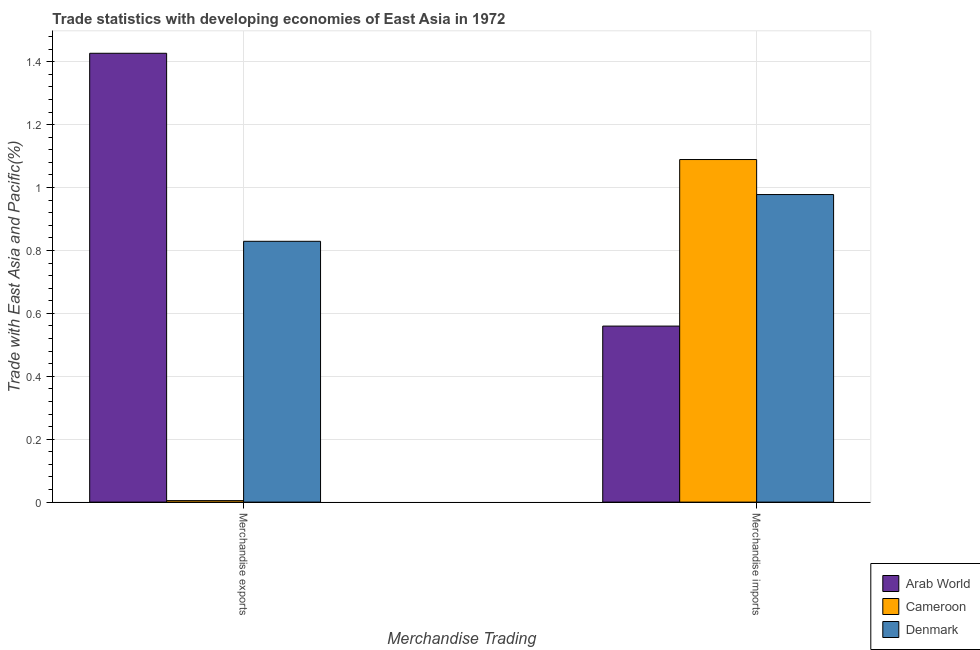How many different coloured bars are there?
Provide a succinct answer. 3. How many groups of bars are there?
Offer a very short reply. 2. Are the number of bars per tick equal to the number of legend labels?
Ensure brevity in your answer.  Yes. Are the number of bars on each tick of the X-axis equal?
Give a very brief answer. Yes. How many bars are there on the 1st tick from the left?
Ensure brevity in your answer.  3. How many bars are there on the 1st tick from the right?
Offer a very short reply. 3. What is the label of the 1st group of bars from the left?
Offer a terse response. Merchandise exports. What is the merchandise exports in Denmark?
Your answer should be compact. 0.83. Across all countries, what is the maximum merchandise exports?
Give a very brief answer. 1.43. Across all countries, what is the minimum merchandise imports?
Make the answer very short. 0.56. In which country was the merchandise exports maximum?
Ensure brevity in your answer.  Arab World. In which country was the merchandise imports minimum?
Make the answer very short. Arab World. What is the total merchandise imports in the graph?
Keep it short and to the point. 2.63. What is the difference between the merchandise imports in Cameroon and that in Denmark?
Offer a terse response. 0.11. What is the difference between the merchandise exports in Denmark and the merchandise imports in Arab World?
Give a very brief answer. 0.27. What is the average merchandise imports per country?
Offer a terse response. 0.88. What is the difference between the merchandise imports and merchandise exports in Denmark?
Keep it short and to the point. 0.15. In how many countries, is the merchandise imports greater than 0.24000000000000002 %?
Keep it short and to the point. 3. What is the ratio of the merchandise exports in Cameroon to that in Arab World?
Ensure brevity in your answer.  0. Is the merchandise imports in Arab World less than that in Denmark?
Make the answer very short. Yes. In how many countries, is the merchandise exports greater than the average merchandise exports taken over all countries?
Offer a terse response. 2. What does the 1st bar from the left in Merchandise imports represents?
Keep it short and to the point. Arab World. What does the 2nd bar from the right in Merchandise imports represents?
Offer a very short reply. Cameroon. Are all the bars in the graph horizontal?
Your answer should be very brief. No. Does the graph contain grids?
Give a very brief answer. Yes. Where does the legend appear in the graph?
Offer a terse response. Bottom right. How many legend labels are there?
Make the answer very short. 3. What is the title of the graph?
Your response must be concise. Trade statistics with developing economies of East Asia in 1972. What is the label or title of the X-axis?
Ensure brevity in your answer.  Merchandise Trading. What is the label or title of the Y-axis?
Make the answer very short. Trade with East Asia and Pacific(%). What is the Trade with East Asia and Pacific(%) of Arab World in Merchandise exports?
Provide a succinct answer. 1.43. What is the Trade with East Asia and Pacific(%) in Cameroon in Merchandise exports?
Make the answer very short. 0. What is the Trade with East Asia and Pacific(%) of Denmark in Merchandise exports?
Keep it short and to the point. 0.83. What is the Trade with East Asia and Pacific(%) of Arab World in Merchandise imports?
Offer a terse response. 0.56. What is the Trade with East Asia and Pacific(%) of Cameroon in Merchandise imports?
Make the answer very short. 1.09. What is the Trade with East Asia and Pacific(%) in Denmark in Merchandise imports?
Provide a short and direct response. 0.98. Across all Merchandise Trading, what is the maximum Trade with East Asia and Pacific(%) in Arab World?
Offer a very short reply. 1.43. Across all Merchandise Trading, what is the maximum Trade with East Asia and Pacific(%) of Cameroon?
Your answer should be very brief. 1.09. Across all Merchandise Trading, what is the maximum Trade with East Asia and Pacific(%) in Denmark?
Keep it short and to the point. 0.98. Across all Merchandise Trading, what is the minimum Trade with East Asia and Pacific(%) in Arab World?
Provide a short and direct response. 0.56. Across all Merchandise Trading, what is the minimum Trade with East Asia and Pacific(%) in Cameroon?
Make the answer very short. 0. Across all Merchandise Trading, what is the minimum Trade with East Asia and Pacific(%) of Denmark?
Keep it short and to the point. 0.83. What is the total Trade with East Asia and Pacific(%) of Arab World in the graph?
Your response must be concise. 1.99. What is the total Trade with East Asia and Pacific(%) of Cameroon in the graph?
Your answer should be compact. 1.09. What is the total Trade with East Asia and Pacific(%) of Denmark in the graph?
Give a very brief answer. 1.81. What is the difference between the Trade with East Asia and Pacific(%) of Arab World in Merchandise exports and that in Merchandise imports?
Provide a succinct answer. 0.87. What is the difference between the Trade with East Asia and Pacific(%) of Cameroon in Merchandise exports and that in Merchandise imports?
Give a very brief answer. -1.08. What is the difference between the Trade with East Asia and Pacific(%) of Denmark in Merchandise exports and that in Merchandise imports?
Offer a very short reply. -0.15. What is the difference between the Trade with East Asia and Pacific(%) in Arab World in Merchandise exports and the Trade with East Asia and Pacific(%) in Cameroon in Merchandise imports?
Provide a succinct answer. 0.34. What is the difference between the Trade with East Asia and Pacific(%) of Arab World in Merchandise exports and the Trade with East Asia and Pacific(%) of Denmark in Merchandise imports?
Provide a succinct answer. 0.45. What is the difference between the Trade with East Asia and Pacific(%) in Cameroon in Merchandise exports and the Trade with East Asia and Pacific(%) in Denmark in Merchandise imports?
Provide a succinct answer. -0.97. What is the average Trade with East Asia and Pacific(%) of Arab World per Merchandise Trading?
Make the answer very short. 0.99. What is the average Trade with East Asia and Pacific(%) of Cameroon per Merchandise Trading?
Provide a succinct answer. 0.55. What is the average Trade with East Asia and Pacific(%) in Denmark per Merchandise Trading?
Provide a short and direct response. 0.9. What is the difference between the Trade with East Asia and Pacific(%) in Arab World and Trade with East Asia and Pacific(%) in Cameroon in Merchandise exports?
Provide a short and direct response. 1.42. What is the difference between the Trade with East Asia and Pacific(%) in Arab World and Trade with East Asia and Pacific(%) in Denmark in Merchandise exports?
Provide a succinct answer. 0.6. What is the difference between the Trade with East Asia and Pacific(%) of Cameroon and Trade with East Asia and Pacific(%) of Denmark in Merchandise exports?
Provide a succinct answer. -0.82. What is the difference between the Trade with East Asia and Pacific(%) in Arab World and Trade with East Asia and Pacific(%) in Cameroon in Merchandise imports?
Your answer should be very brief. -0.53. What is the difference between the Trade with East Asia and Pacific(%) of Arab World and Trade with East Asia and Pacific(%) of Denmark in Merchandise imports?
Ensure brevity in your answer.  -0.42. What is the difference between the Trade with East Asia and Pacific(%) in Cameroon and Trade with East Asia and Pacific(%) in Denmark in Merchandise imports?
Offer a very short reply. 0.11. What is the ratio of the Trade with East Asia and Pacific(%) in Arab World in Merchandise exports to that in Merchandise imports?
Your response must be concise. 2.55. What is the ratio of the Trade with East Asia and Pacific(%) of Cameroon in Merchandise exports to that in Merchandise imports?
Your response must be concise. 0. What is the ratio of the Trade with East Asia and Pacific(%) of Denmark in Merchandise exports to that in Merchandise imports?
Make the answer very short. 0.85. What is the difference between the highest and the second highest Trade with East Asia and Pacific(%) of Arab World?
Offer a terse response. 0.87. What is the difference between the highest and the second highest Trade with East Asia and Pacific(%) in Cameroon?
Ensure brevity in your answer.  1.08. What is the difference between the highest and the second highest Trade with East Asia and Pacific(%) in Denmark?
Provide a short and direct response. 0.15. What is the difference between the highest and the lowest Trade with East Asia and Pacific(%) of Arab World?
Give a very brief answer. 0.87. What is the difference between the highest and the lowest Trade with East Asia and Pacific(%) in Cameroon?
Offer a very short reply. 1.08. What is the difference between the highest and the lowest Trade with East Asia and Pacific(%) in Denmark?
Provide a short and direct response. 0.15. 